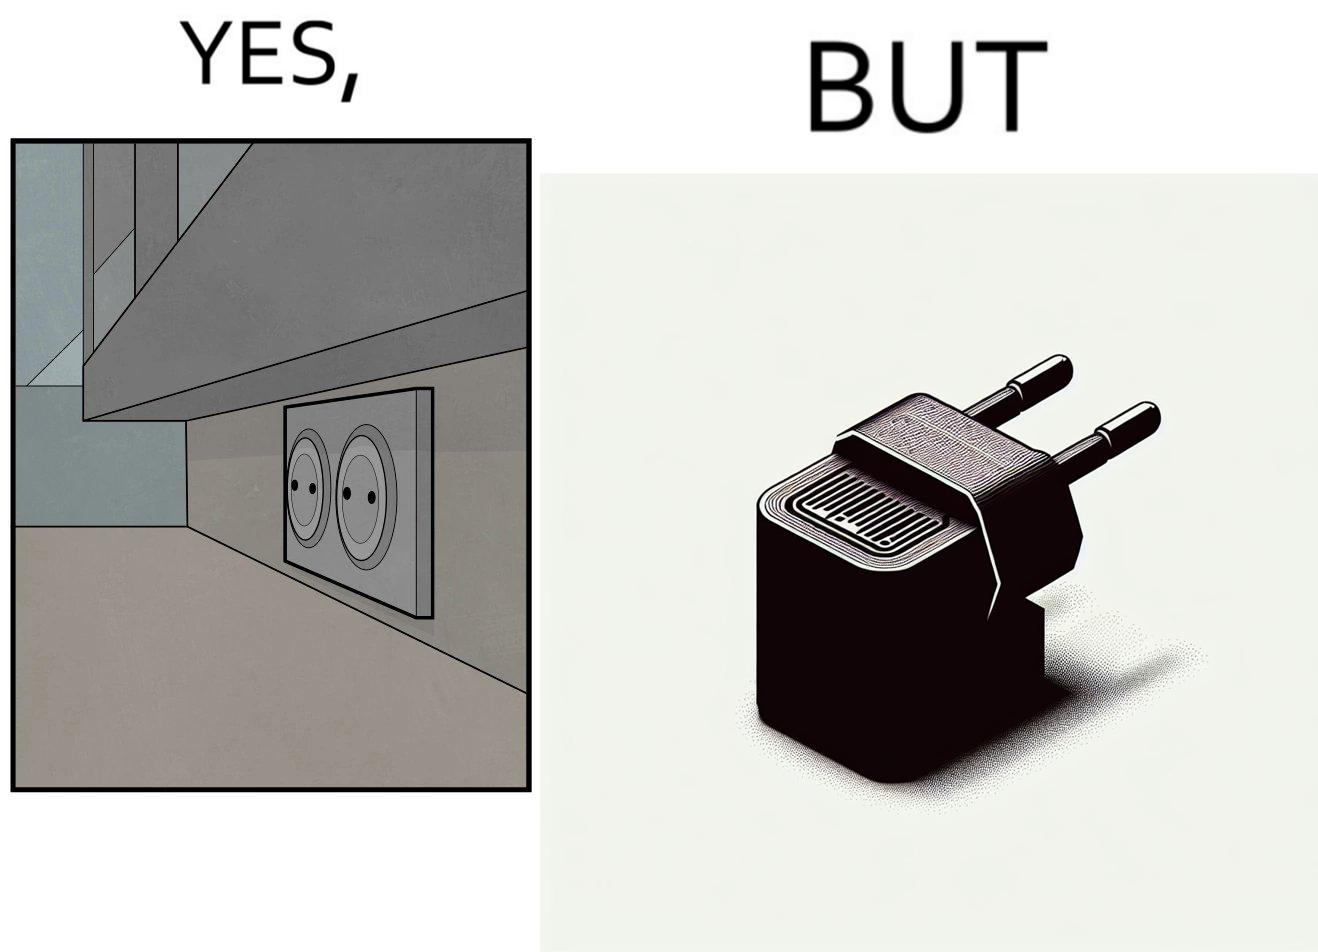Why is this image considered satirical? The image is funny, as there are two electrical sockets side-by-side, but the adapter is shaped in such a way, that if two adapters are inserted into the two sockets, they will butt into each other, leading to inconvenience. 